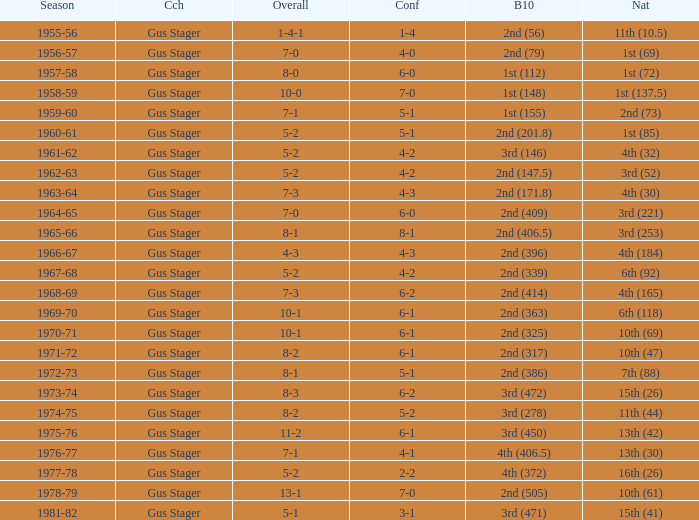What is the Coach with a Big Ten that is 2nd (79)? Gus Stager. 